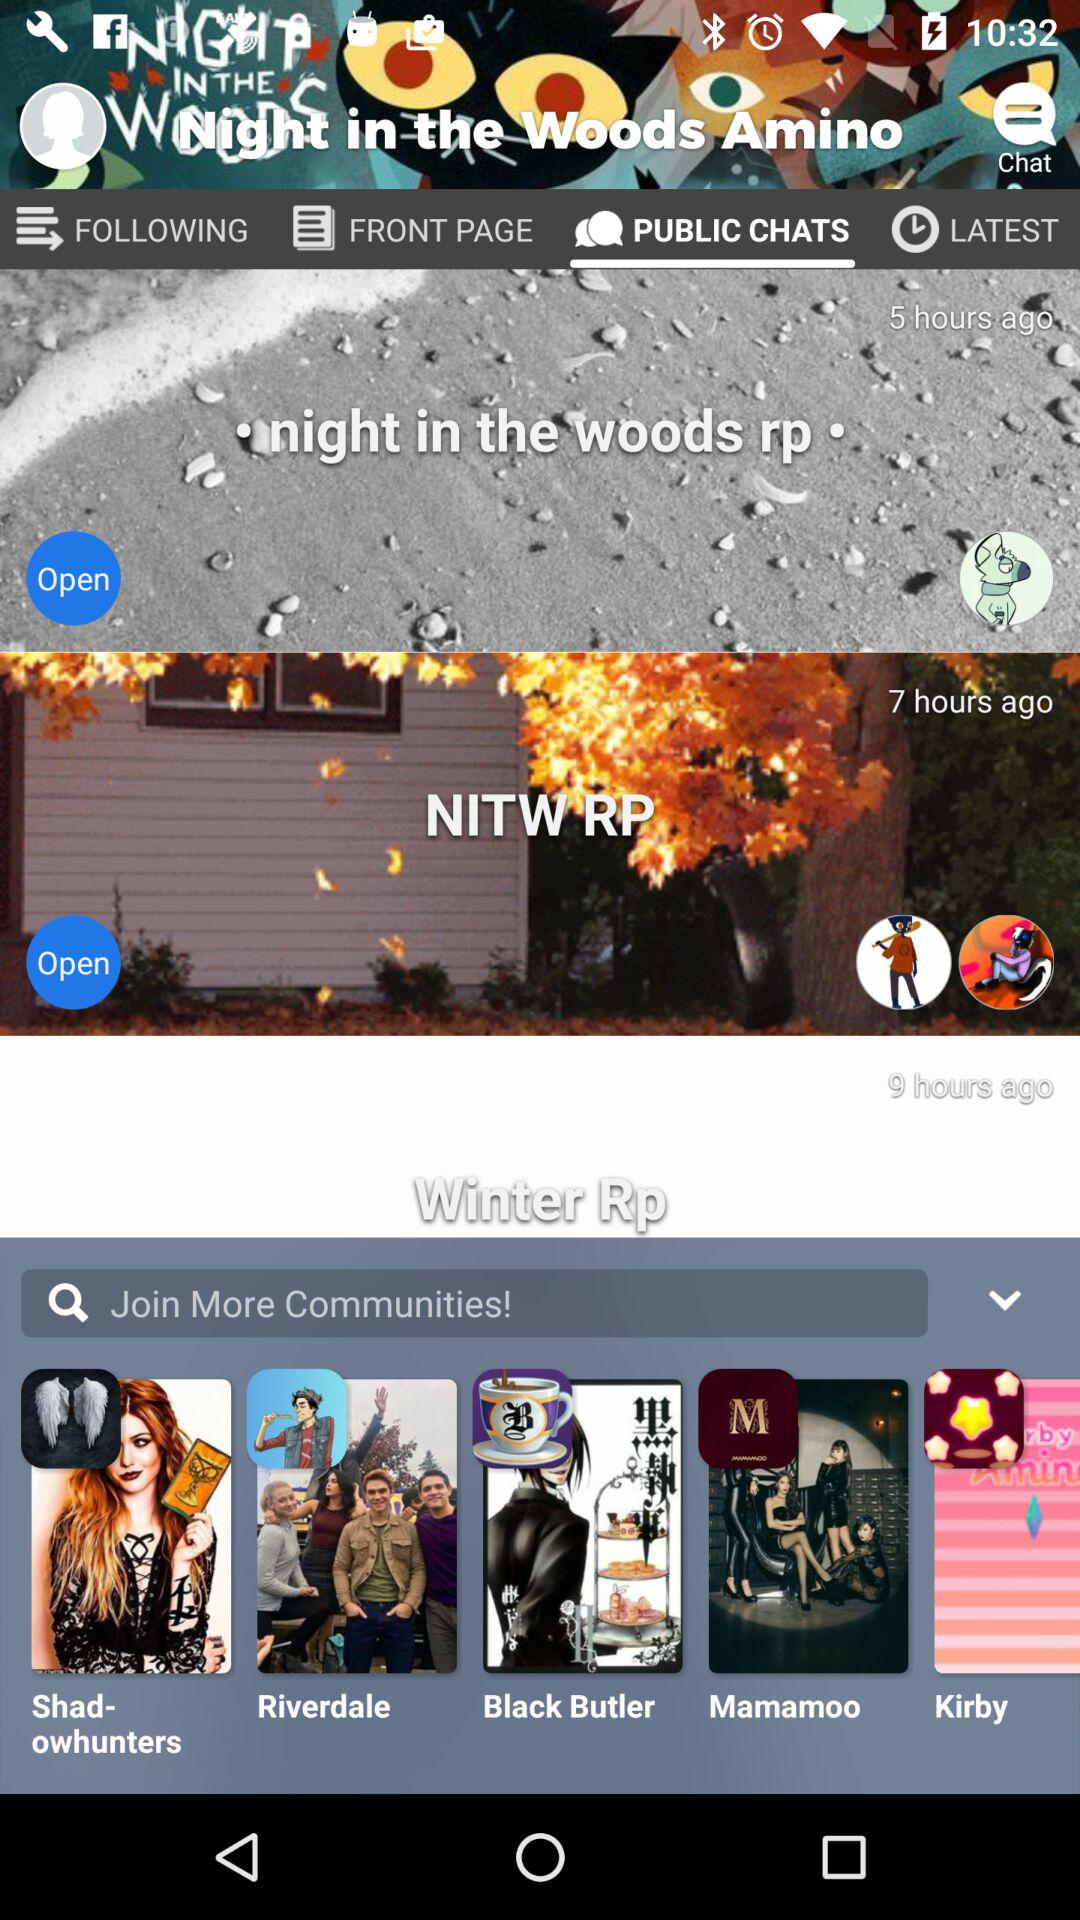When did the last conversation happen in "NITW RP"? The last conversation happened in "NITW RP" 7 hours ago. 